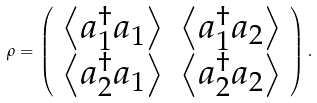Convert formula to latex. <formula><loc_0><loc_0><loc_500><loc_500>\rho = \left ( \begin{array} { c c } \left \langle a _ { 1 } ^ { \dag } a _ { 1 } \right \rangle & \left \langle a _ { 1 } ^ { \dag } a _ { 2 } \right \rangle \\ \left \langle a _ { 2 } ^ { \dag } a _ { 1 } \right \rangle & \left \langle a _ { 2 } ^ { \dag } a _ { 2 } \right \rangle \end{array} \right ) .</formula> 